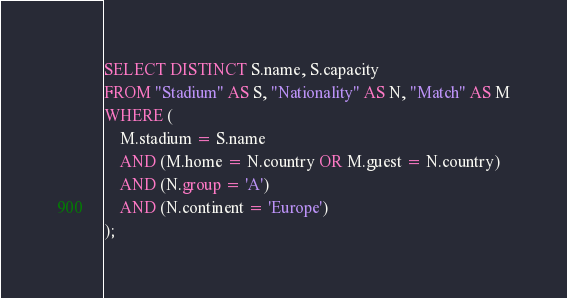Convert code to text. <code><loc_0><loc_0><loc_500><loc_500><_SQL_>SELECT DISTINCT S.name, S.capacity
FROM "Stadium" AS S, "Nationality" AS N, "Match" AS M
WHERE (
	M.stadium = S.name
	AND (M.home = N.country OR M.guest = N.country)
	AND (N.group = 'A')
	AND (N.continent = 'Europe')
);
</code> 